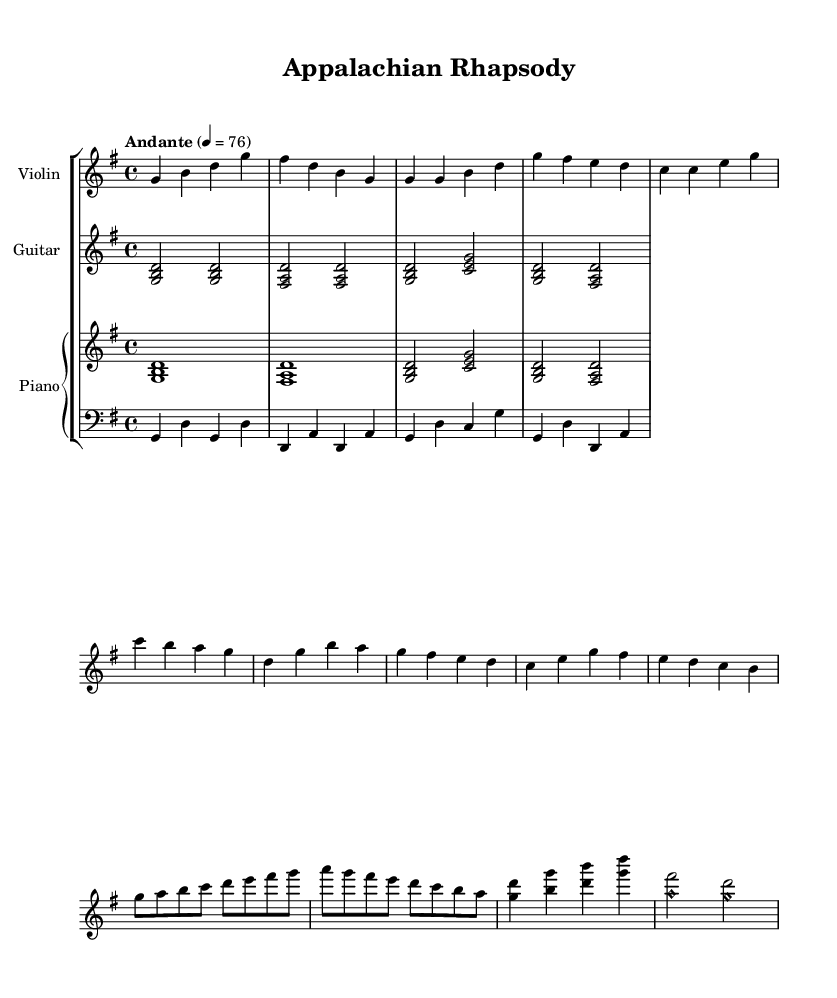What is the key signature of this music? The key signature is G major, which has one sharp (F#). This is indicated in the `\key g \major` command in the global variable setup section of the LilyPond code.
Answer: G major What is the time signature of this music? The time signature is 4/4, which indicates four beats per measure. This is specified in the `\time 4/4` command in the global variable setup section of the LilyPond code.
Answer: 4/4 What is the tempo marking of this piece? The tempo marking is "Andante" at a quarter note equals 76 beats per minute. This is stated in the `\tempo` line which defines the speed of the music.
Answer: Andante, 76 How many measures are in the violin solo section? The violin solo section is composed of 8 measures as indicated by the sequence of notes and bar lines in the violin solo part of the score.
Answer: 8 List the instruments featured in this piece. The instruments featured are Violin, Guitar, Piano, and Bass, as stated in the staff group headers in the score.
Answer: Violin, Guitar, Piano, Bass What is the highest pitch note played in the violin solo section? The highest pitch note in the violin solo section is G, which is indicated by the note in the second half of the violin solo, specifically at the beginning of the measure containing the note "g'".
Answer: G Which section of the piece features the intricate violin solos? The violin solo section specifically labeled as “Violin Solo” includes the intricate parts that are meant to showcase the violin. This section can be found clearly marked in the score.
Answer: Violin Solo 